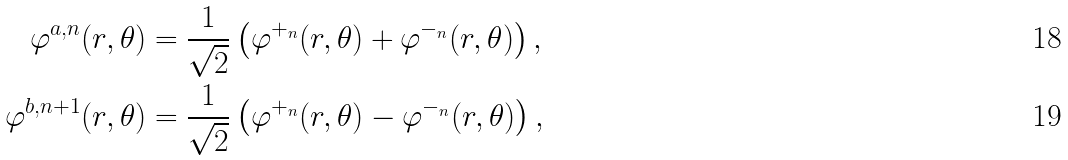<formula> <loc_0><loc_0><loc_500><loc_500>\varphi ^ { a , n } ( r , \theta ) & = \frac { 1 } { \sqrt { 2 } } \left ( \varphi ^ { + _ { n } } ( r , \theta ) + \varphi ^ { - _ { n } } ( r , \theta ) \right ) , \\ \varphi ^ { b , n + 1 } ( r , \theta ) & = \frac { 1 } { \sqrt { 2 } } \left ( \varphi ^ { + _ { n } } ( r , \theta ) - \varphi ^ { - _ { n } } ( r , \theta ) \right ) ,</formula> 